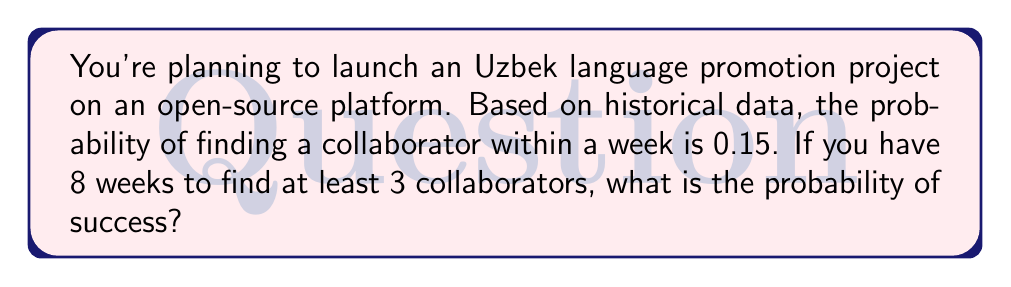What is the answer to this math problem? Let's approach this step-by-step:

1) First, we need to calculate the probability of not finding a collaborator in a week:
   $P(\text{no collaborator}) = 1 - 0.15 = 0.85$

2) Now, the probability of not finding at least 3 collaborators in 8 weeks is equivalent to finding 0, 1, or 2 collaborators. We can use the binomial distribution for this:

   $$P(X < 3) = P(X=0) + P(X=1) + P(X=2)$$

   Where $X$ is the number of collaborators found, and:
   
   $$P(X=k) = \binom{n}{k} p^k (1-p)^{n-k}$$

   Here, $n=8$ (weeks), $p=0.15$ (probability of success per week)

3) Let's calculate each term:

   $$P(X=0) = \binom{8}{0} 0.15^0 0.85^8 = 0.2725$$
   
   $$P(X=1) = \binom{8}{1} 0.15^1 0.85^7 = 0.3847$$
   
   $$P(X=2) = \binom{8}{2} 0.15^2 0.85^6 = 0.2376$$

4) Sum these probabilities:

   $$P(X < 3) = 0.2725 + 0.3847 + 0.2376 = 0.8948$$

5) The probability of success (finding at least 3 collaborators) is the complement of this:

   $$P(X \geq 3) = 1 - P(X < 3) = 1 - 0.8948 = 0.1052$$

Therefore, the probability of finding at least 3 collaborators in 8 weeks is approximately 0.1052 or 10.52%.
Answer: 0.1052 